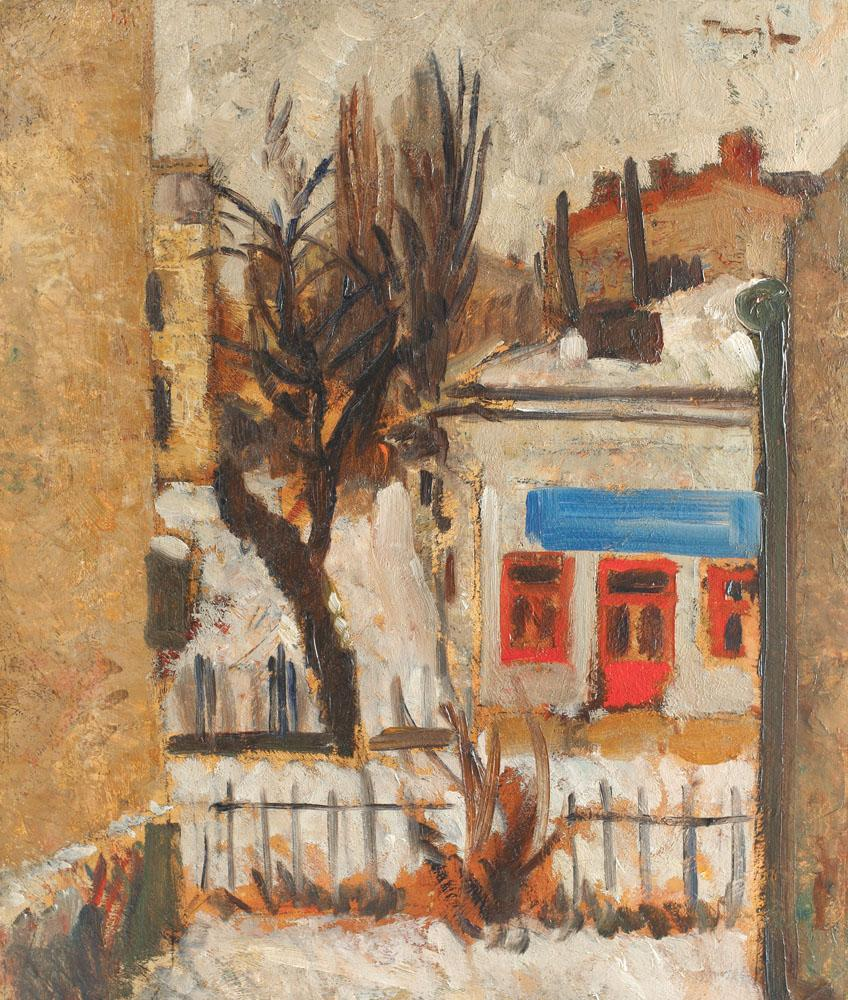What time of day does this painting depict, and how can you tell? The mood of the painting suggests it may represent an early morning setting. The muted lighting and long shadows imply that the sun is low on the horizon, casting a warm yet weak light on the structures and the street. The lack of activity also supports this idea; there are no people or signs of movement visible in the scene. Additionally, the lamppost, now unlit, indicates that the night has passed, and the first light of the day has arrived, allowing us to witness the peaceful transition from night to day. 